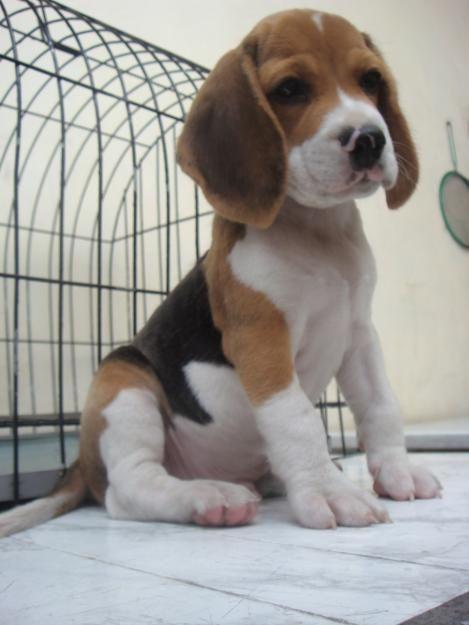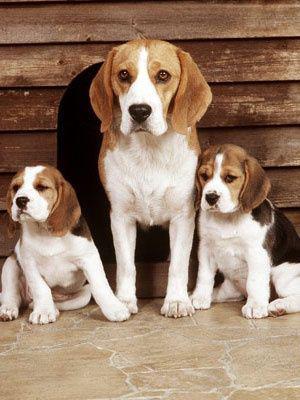The first image is the image on the left, the second image is the image on the right. For the images shown, is this caption "There is one puppy sitting by itself in one of the images." true? Answer yes or no. Yes. 